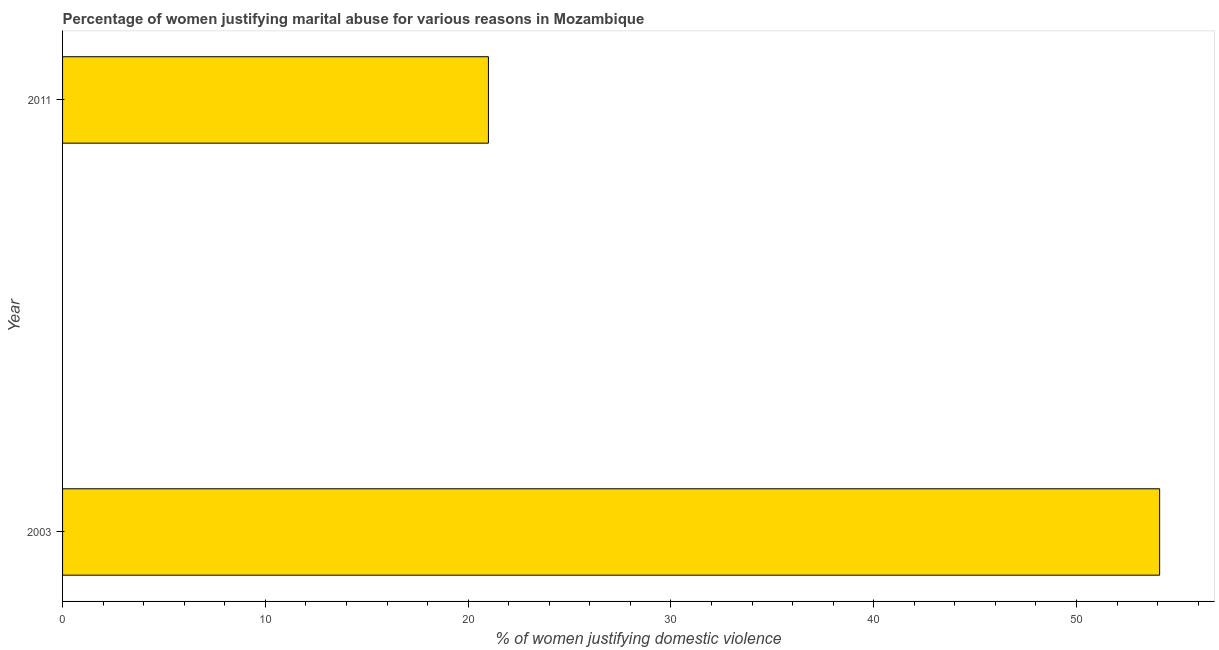Does the graph contain any zero values?
Give a very brief answer. No. Does the graph contain grids?
Make the answer very short. No. What is the title of the graph?
Offer a terse response. Percentage of women justifying marital abuse for various reasons in Mozambique. What is the label or title of the X-axis?
Provide a short and direct response. % of women justifying domestic violence. What is the percentage of women justifying marital abuse in 2003?
Make the answer very short. 54.1. Across all years, what is the maximum percentage of women justifying marital abuse?
Your answer should be very brief. 54.1. In which year was the percentage of women justifying marital abuse minimum?
Give a very brief answer. 2011. What is the sum of the percentage of women justifying marital abuse?
Keep it short and to the point. 75.1. What is the difference between the percentage of women justifying marital abuse in 2003 and 2011?
Offer a very short reply. 33.1. What is the average percentage of women justifying marital abuse per year?
Provide a succinct answer. 37.55. What is the median percentage of women justifying marital abuse?
Provide a succinct answer. 37.55. What is the ratio of the percentage of women justifying marital abuse in 2003 to that in 2011?
Provide a short and direct response. 2.58. Is the percentage of women justifying marital abuse in 2003 less than that in 2011?
Your response must be concise. No. In how many years, is the percentage of women justifying marital abuse greater than the average percentage of women justifying marital abuse taken over all years?
Your answer should be compact. 1. Are all the bars in the graph horizontal?
Provide a succinct answer. Yes. What is the % of women justifying domestic violence of 2003?
Offer a terse response. 54.1. What is the % of women justifying domestic violence in 2011?
Ensure brevity in your answer.  21. What is the difference between the % of women justifying domestic violence in 2003 and 2011?
Give a very brief answer. 33.1. What is the ratio of the % of women justifying domestic violence in 2003 to that in 2011?
Your answer should be compact. 2.58. 